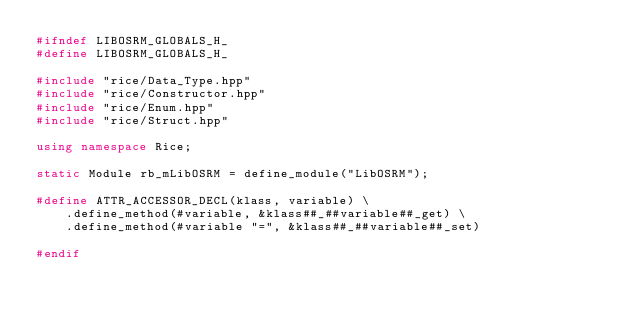Convert code to text. <code><loc_0><loc_0><loc_500><loc_500><_C++_>#ifndef LIBOSRM_GLOBALS_H_
#define LIBOSRM_GLOBALS_H_

#include "rice/Data_Type.hpp"
#include "rice/Constructor.hpp"
#include "rice/Enum.hpp"
#include "rice/Struct.hpp"

using namespace Rice;

static Module rb_mLibOSRM = define_module("LibOSRM");

#define ATTR_ACCESSOR_DECL(klass, variable) \
    .define_method(#variable, &klass##_##variable##_get) \
    .define_method(#variable "=", &klass##_##variable##_set)

#endif
</code> 